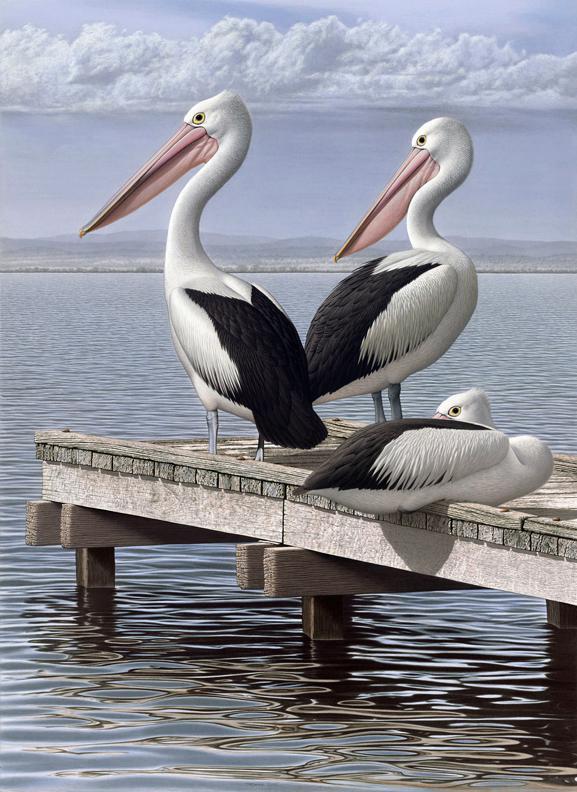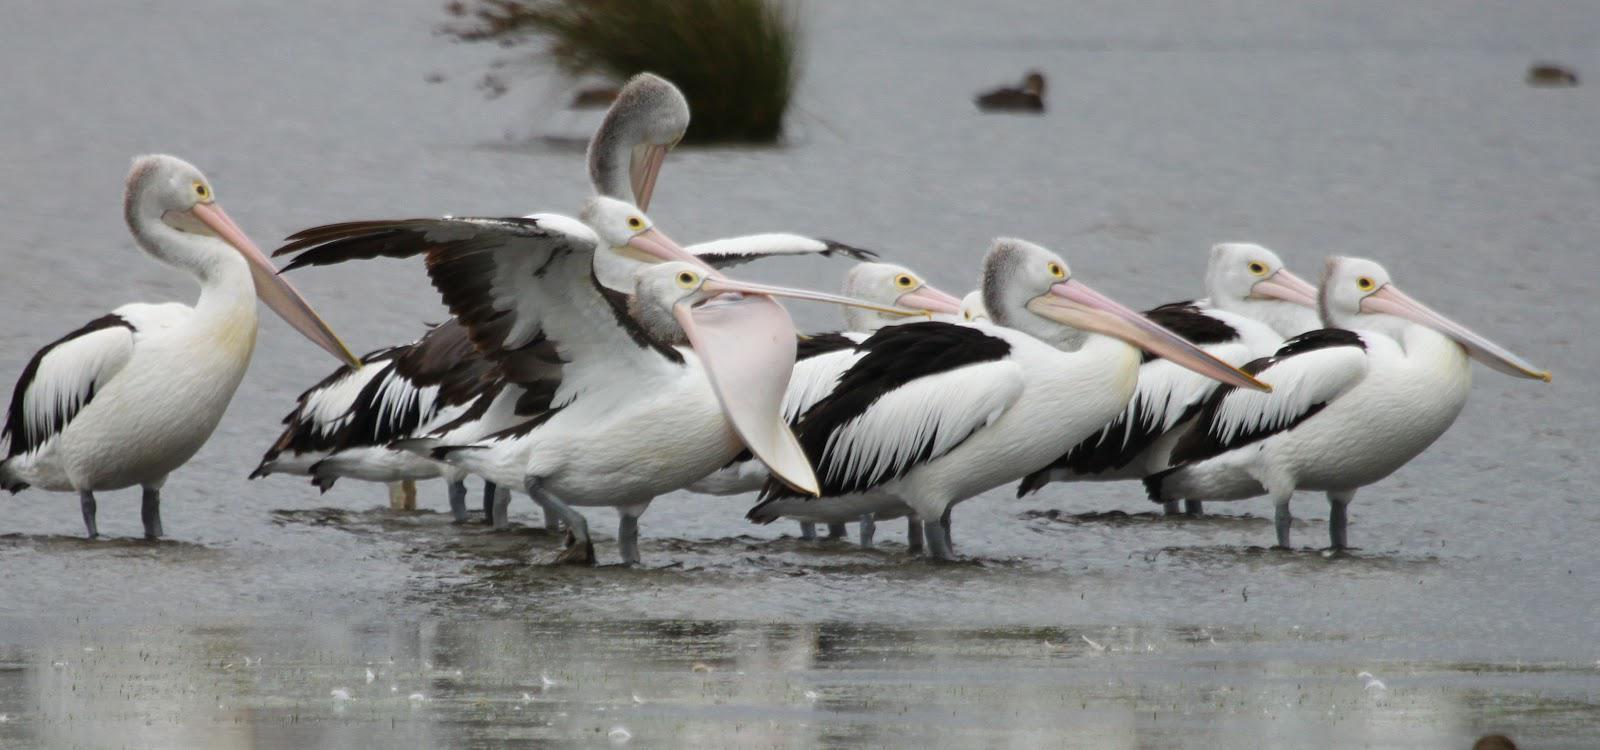The first image is the image on the left, the second image is the image on the right. For the images shown, is this caption "An image shows at least two pelicans standing on a flat manmade platform over the water." true? Answer yes or no. Yes. 